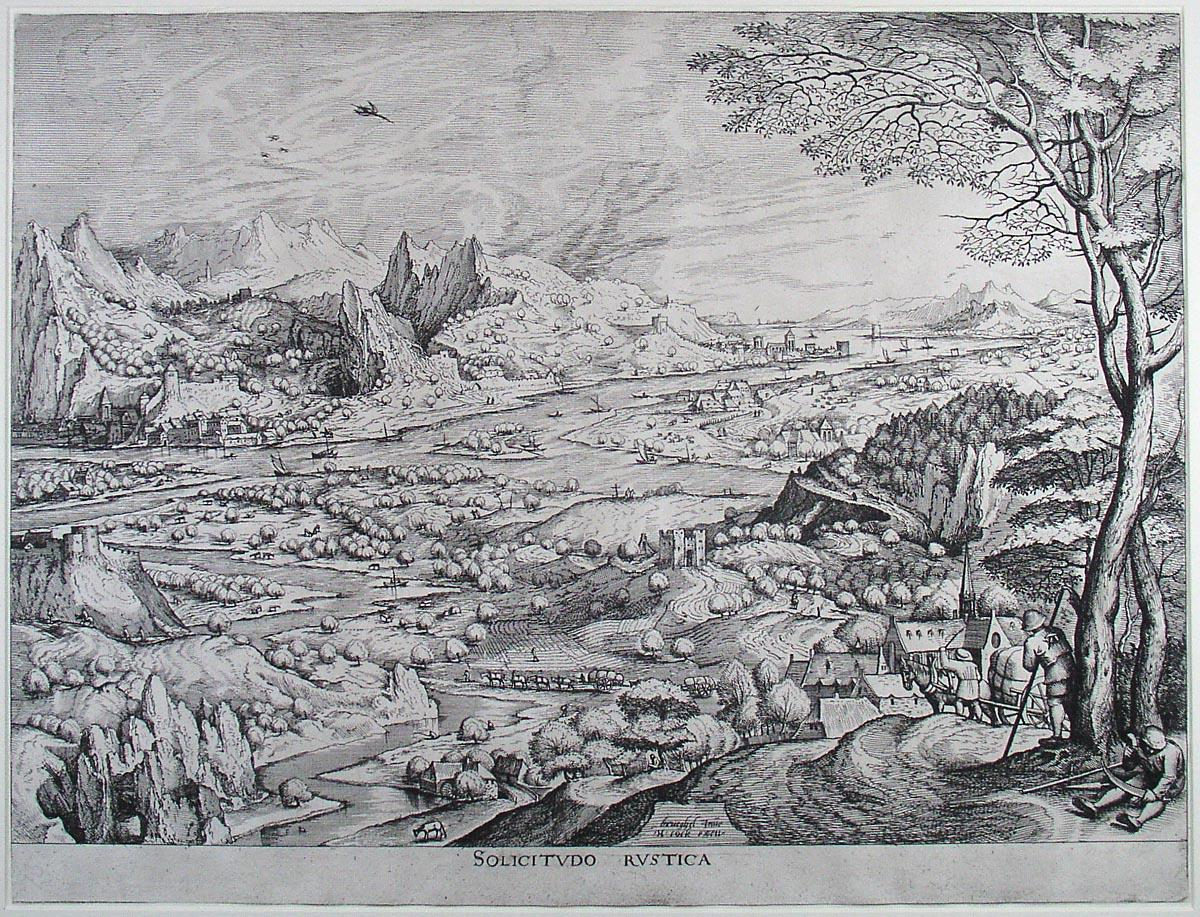Imagine you are one of the people in this scene. Describe your day. As a farmer working the fertile fields by the river, my day begins at dawn. The first light of morning illuminates the mist-covered landscape as I gather my tools and make my way to the fields. With the rhythmic sound of flowing water from the river close by, I till the soil and tend to the crops, sharing labor and stories with my fellow villagers. The air is filled with the scent of earth and fresh vegetation, and the distant mountains provide a constant, majestic backdrop to our efforts. As the sun climbs higher, warming the surroundings, we take a break under the shade of a tall tree, savoring a simple meal. The afternoon is spent ensuring our livestock are fed and healthy, and repairing any equipment we may need. By dusk, as the sky is painted with hues of orange and purple, I head back to my humble abode, feeling a deep sense of contentment and connection to the land. 